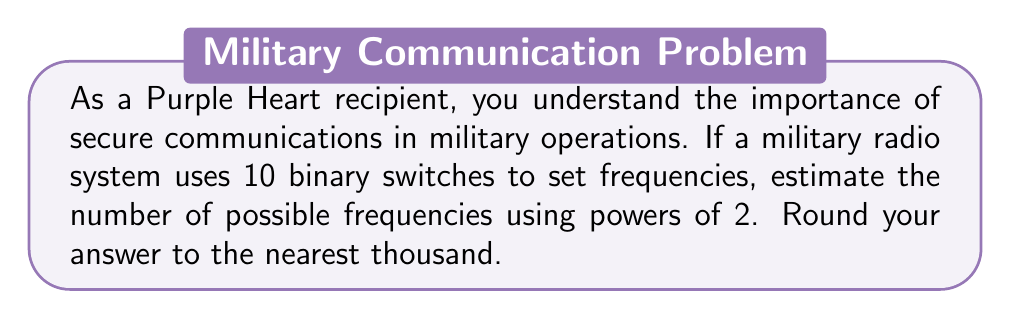What is the answer to this math problem? Let's approach this step-by-step:

1) Each binary switch has two possible states: on or off. This can be represented as 2 choices.

2) We have 10 such switches, each with 2 choices.

3) The total number of combinations is calculated by multiplying the number of choices for each switch:

   $2 \times 2 \times 2 \times ... \text{ (10 times) }$

4) This can be written as a power of 2:

   $2^{10}$

5) Let's calculate this:
   
   $2^{10} = 1024$

6) Rounding to the nearest thousand:
   
   1024 rounds to 1000

Therefore, we estimate that there are approximately 1000 possible frequencies.
Answer: $1000$ frequencies 